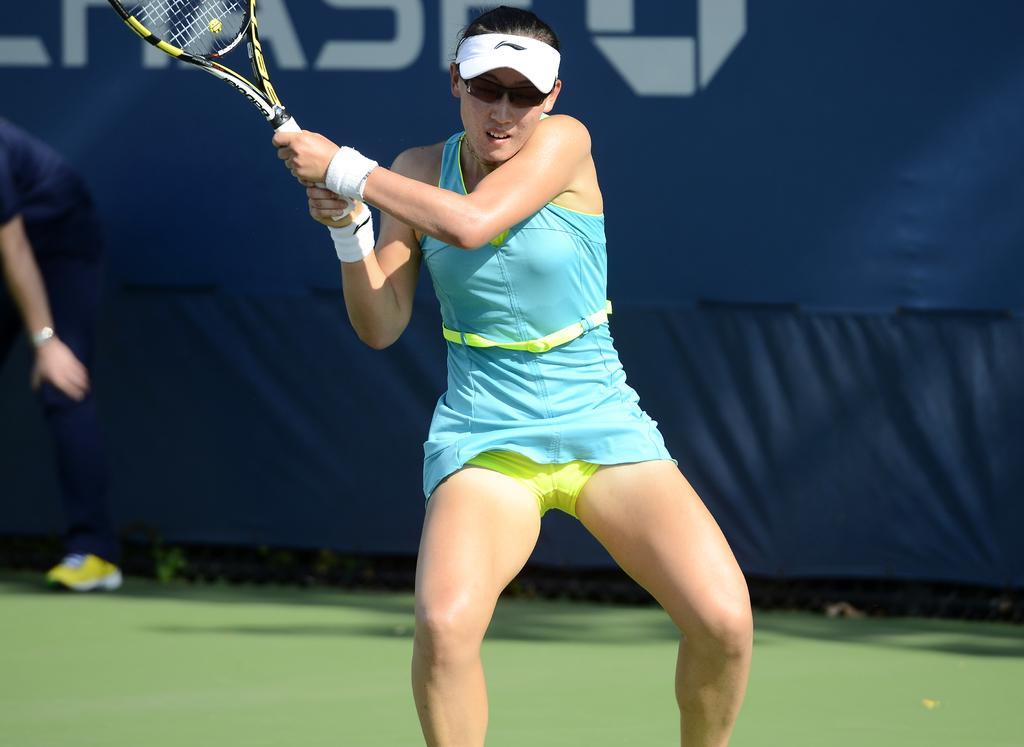Can you describe this image briefly? In a picture a woman is playing game badminton with a racket in her hand and she is wearing cap and glasses and she is wearing a blue dress behind her there is a one person standing and behind him them one blue curtain with text on it. 